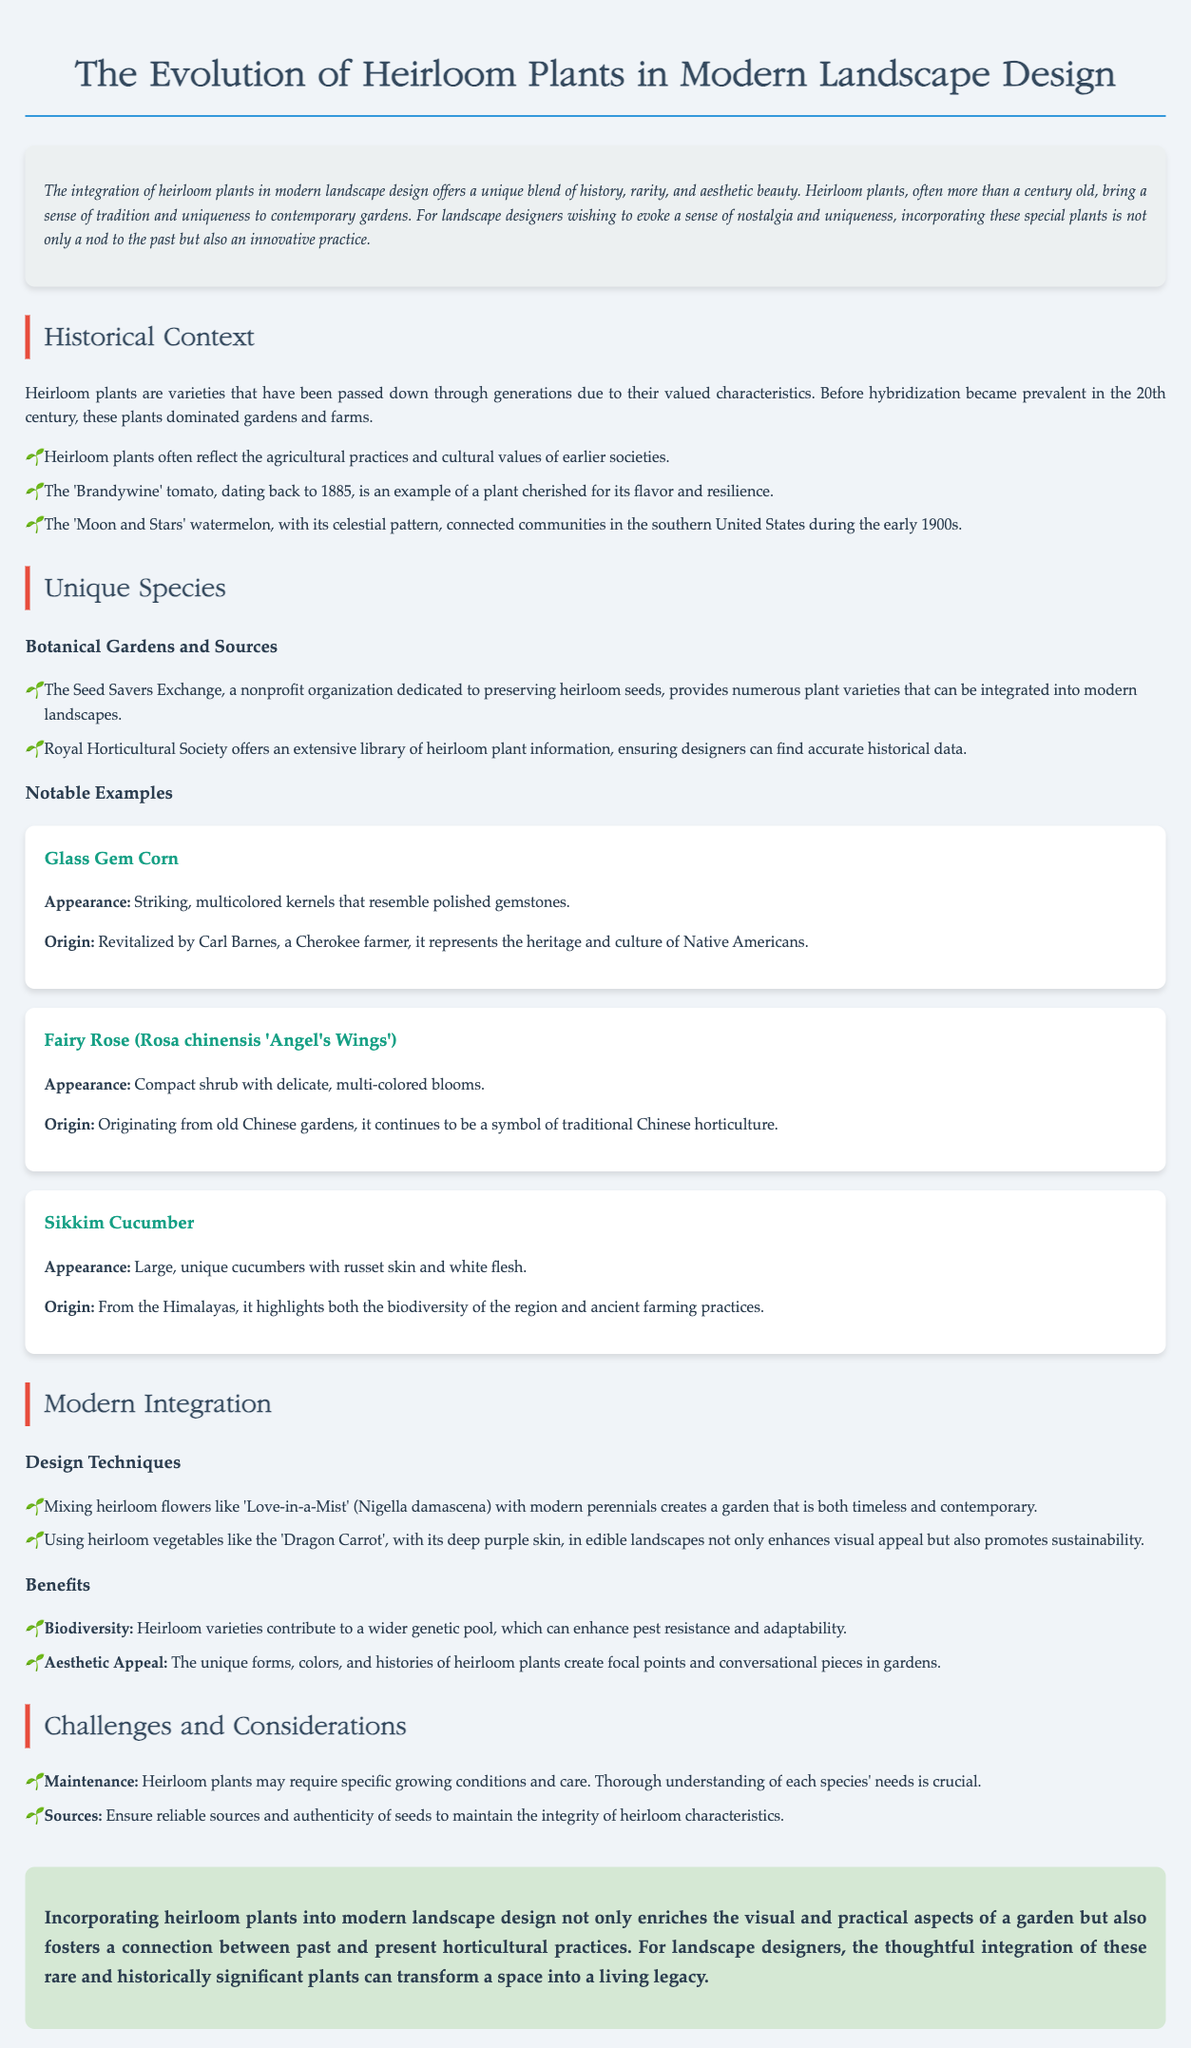what is the title of the document? The title is specifically stated at the top of the document.
Answer: The Evolution of Heirloom Plants in Modern Landscape Design what year is the 'Brandywine' tomato from? The document mentions the 'Brandywine' tomato date in the historical context section.
Answer: 1885 who revitalized Glass Gem Corn? The document provides the name of the individual associated with Glass Gem Corn in the unique species section.
Answer: Carl Barnes what organization is dedicated to preserving heirloom seeds? The document mentions this organization in the sources section.
Answer: Seed Savers Exchange what is one benefit of incorporating heirloom plants? The benefits are listed in the benefits section, with multiple options provided.
Answer: Biodiversity which heirloom plant is described as having a 'deep purple skin'? The document identifies this plant in the modern integration section.
Answer: Dragon Carrot what challenges are mentioned regarding heirloom plants? The document lists challenges that can be found in the challenges and considerations section.
Answer: Maintenance where does the Sikkim Cucumber originate from? The document gives the origin information in the notable examples section for Sikkim Cucumber.
Answer: Himalayas what is a characteristic of the 'Moon and Stars' watermelon? The document describes this aspect in the historical context section.
Answer: Celestial pattern 